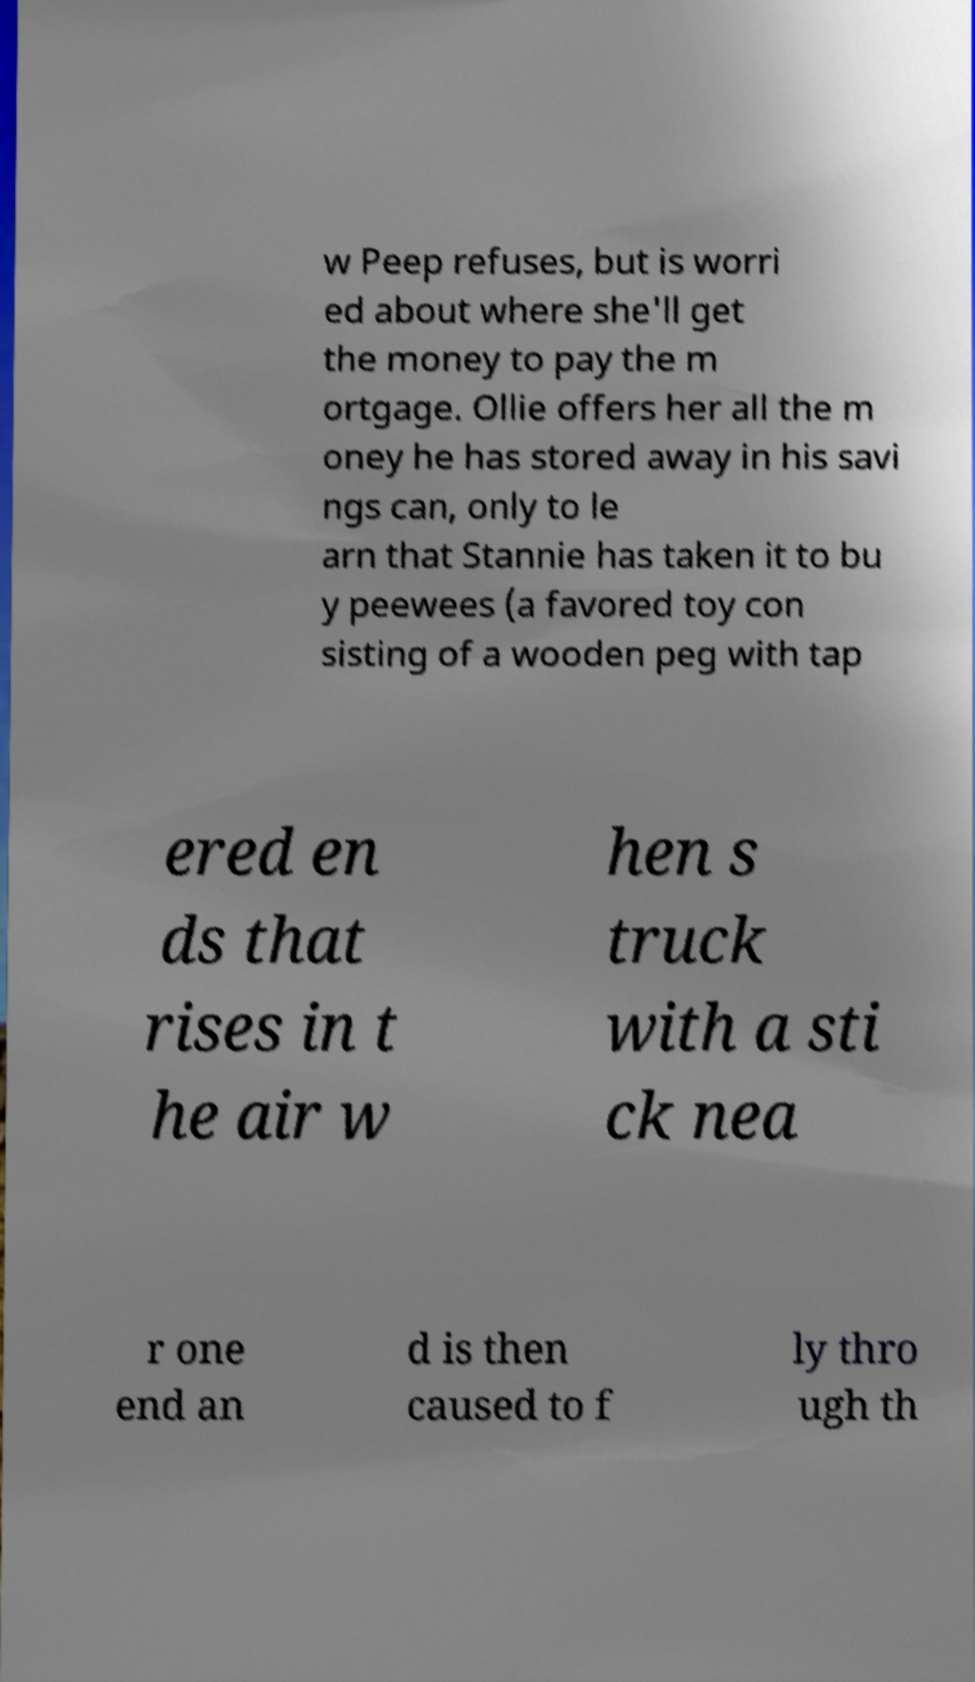Could you assist in decoding the text presented in this image and type it out clearly? w Peep refuses, but is worri ed about where she'll get the money to pay the m ortgage. Ollie offers her all the m oney he has stored away in his savi ngs can, only to le arn that Stannie has taken it to bu y peewees (a favored toy con sisting of a wooden peg with tap ered en ds that rises in t he air w hen s truck with a sti ck nea r one end an d is then caused to f ly thro ugh th 